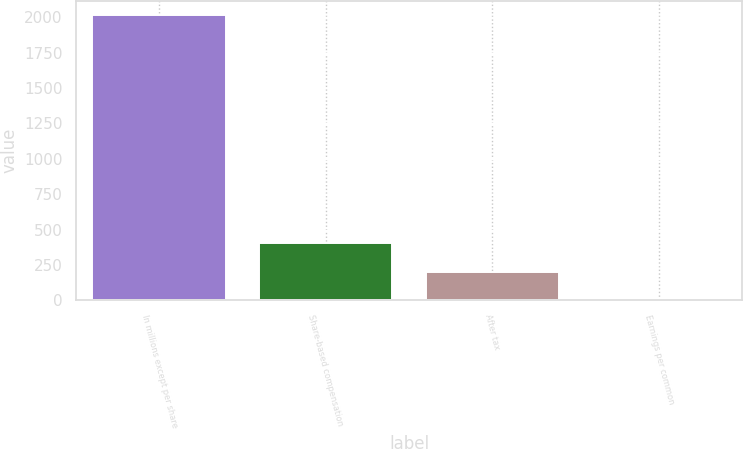Convert chart. <chart><loc_0><loc_0><loc_500><loc_500><bar_chart><fcel>In millions except per share<fcel>Share-based compensation<fcel>After tax<fcel>Earnings per common<nl><fcel>2015<fcel>403.06<fcel>201.57<fcel>0.08<nl></chart> 